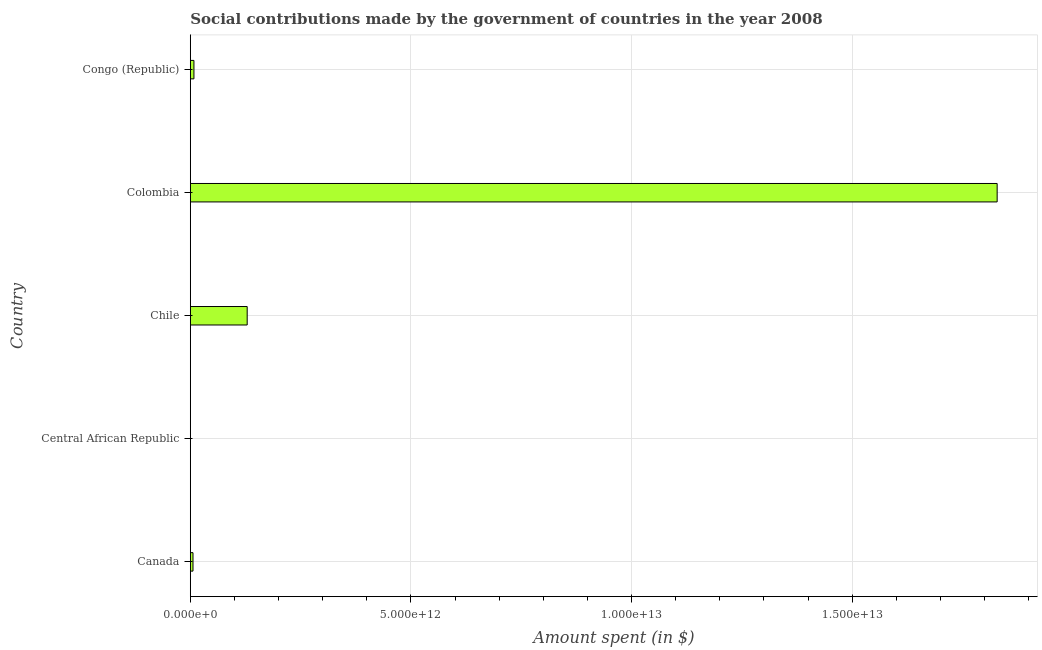Does the graph contain any zero values?
Your answer should be very brief. No. Does the graph contain grids?
Ensure brevity in your answer.  Yes. What is the title of the graph?
Offer a terse response. Social contributions made by the government of countries in the year 2008. What is the label or title of the X-axis?
Provide a succinct answer. Amount spent (in $). What is the amount spent in making social contributions in Chile?
Offer a terse response. 1.29e+12. Across all countries, what is the maximum amount spent in making social contributions?
Your answer should be very brief. 1.83e+13. Across all countries, what is the minimum amount spent in making social contributions?
Make the answer very short. 2.00e+09. In which country was the amount spent in making social contributions minimum?
Offer a terse response. Central African Republic. What is the sum of the amount spent in making social contributions?
Offer a terse response. 1.97e+13. What is the difference between the amount spent in making social contributions in Colombia and Congo (Republic)?
Provide a short and direct response. 1.82e+13. What is the average amount spent in making social contributions per country?
Provide a succinct answer. 3.94e+12. What is the median amount spent in making social contributions?
Keep it short and to the point. 8.27e+1. What is the ratio of the amount spent in making social contributions in Canada to that in Chile?
Offer a very short reply. 0.05. Is the amount spent in making social contributions in Canada less than that in Colombia?
Provide a short and direct response. Yes. What is the difference between the highest and the second highest amount spent in making social contributions?
Your response must be concise. 1.70e+13. What is the difference between the highest and the lowest amount spent in making social contributions?
Provide a short and direct response. 1.83e+13. In how many countries, is the amount spent in making social contributions greater than the average amount spent in making social contributions taken over all countries?
Your answer should be compact. 1. What is the difference between two consecutive major ticks on the X-axis?
Offer a terse response. 5.00e+12. Are the values on the major ticks of X-axis written in scientific E-notation?
Your answer should be very brief. Yes. What is the Amount spent (in $) in Canada?
Offer a very short reply. 6.13e+1. What is the Amount spent (in $) in Central African Republic?
Keep it short and to the point. 2.00e+09. What is the Amount spent (in $) of Chile?
Offer a very short reply. 1.29e+12. What is the Amount spent (in $) in Colombia?
Your answer should be compact. 1.83e+13. What is the Amount spent (in $) of Congo (Republic)?
Offer a terse response. 8.27e+1. What is the difference between the Amount spent (in $) in Canada and Central African Republic?
Offer a very short reply. 5.93e+1. What is the difference between the Amount spent (in $) in Canada and Chile?
Keep it short and to the point. -1.23e+12. What is the difference between the Amount spent (in $) in Canada and Colombia?
Your response must be concise. -1.82e+13. What is the difference between the Amount spent (in $) in Canada and Congo (Republic)?
Offer a terse response. -2.14e+1. What is the difference between the Amount spent (in $) in Central African Republic and Chile?
Your answer should be compact. -1.29e+12. What is the difference between the Amount spent (in $) in Central African Republic and Colombia?
Your answer should be very brief. -1.83e+13. What is the difference between the Amount spent (in $) in Central African Republic and Congo (Republic)?
Ensure brevity in your answer.  -8.07e+1. What is the difference between the Amount spent (in $) in Chile and Colombia?
Keep it short and to the point. -1.70e+13. What is the difference between the Amount spent (in $) in Chile and Congo (Republic)?
Make the answer very short. 1.21e+12. What is the difference between the Amount spent (in $) in Colombia and Congo (Republic)?
Offer a very short reply. 1.82e+13. What is the ratio of the Amount spent (in $) in Canada to that in Central African Republic?
Make the answer very short. 30.64. What is the ratio of the Amount spent (in $) in Canada to that in Chile?
Your answer should be very brief. 0.05. What is the ratio of the Amount spent (in $) in Canada to that in Colombia?
Ensure brevity in your answer.  0. What is the ratio of the Amount spent (in $) in Canada to that in Congo (Republic)?
Offer a terse response. 0.74. What is the ratio of the Amount spent (in $) in Central African Republic to that in Chile?
Your answer should be very brief. 0. What is the ratio of the Amount spent (in $) in Central African Republic to that in Congo (Republic)?
Offer a terse response. 0.02. What is the ratio of the Amount spent (in $) in Chile to that in Colombia?
Provide a short and direct response. 0.07. What is the ratio of the Amount spent (in $) in Chile to that in Congo (Republic)?
Your answer should be very brief. 15.59. What is the ratio of the Amount spent (in $) in Colombia to that in Congo (Republic)?
Your answer should be compact. 221.06. 